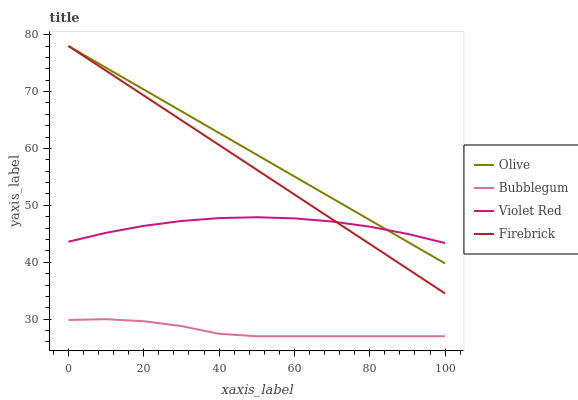Does Violet Red have the minimum area under the curve?
Answer yes or no. No. Does Violet Red have the maximum area under the curve?
Answer yes or no. No. Is Violet Red the smoothest?
Answer yes or no. No. Is Firebrick the roughest?
Answer yes or no. No. Does Firebrick have the lowest value?
Answer yes or no. No. Does Violet Red have the highest value?
Answer yes or no. No. Is Bubblegum less than Firebrick?
Answer yes or no. Yes. Is Olive greater than Bubblegum?
Answer yes or no. Yes. Does Bubblegum intersect Firebrick?
Answer yes or no. No. 